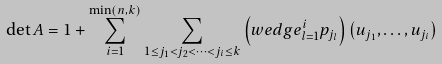Convert formula to latex. <formula><loc_0><loc_0><loc_500><loc_500>\det A = 1 + \sum _ { i = 1 } ^ { \min ( n , k ) } \sum _ { 1 \leq j _ { 1 } < j _ { 2 } < \dots < j _ { i } \leq k } \left ( w e d g e _ { l = 1 } ^ { i } p _ { j _ { l } } \right ) \left ( u _ { j _ { 1 } } , \dots , u _ { j _ { i } } \right )</formula> 